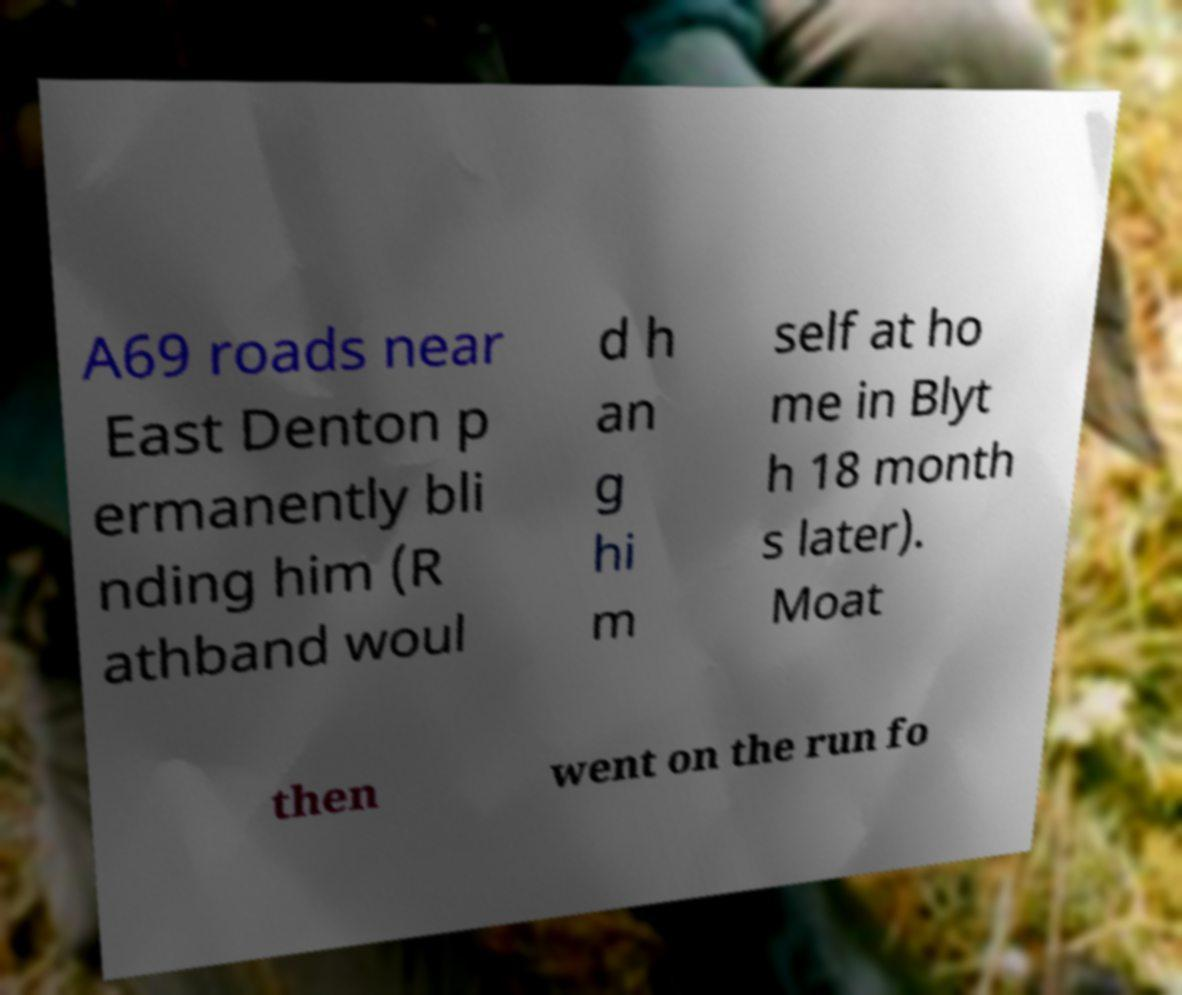Can you accurately transcribe the text from the provided image for me? A69 roads near East Denton p ermanently bli nding him (R athband woul d h an g hi m self at ho me in Blyt h 18 month s later). Moat then went on the run fo 